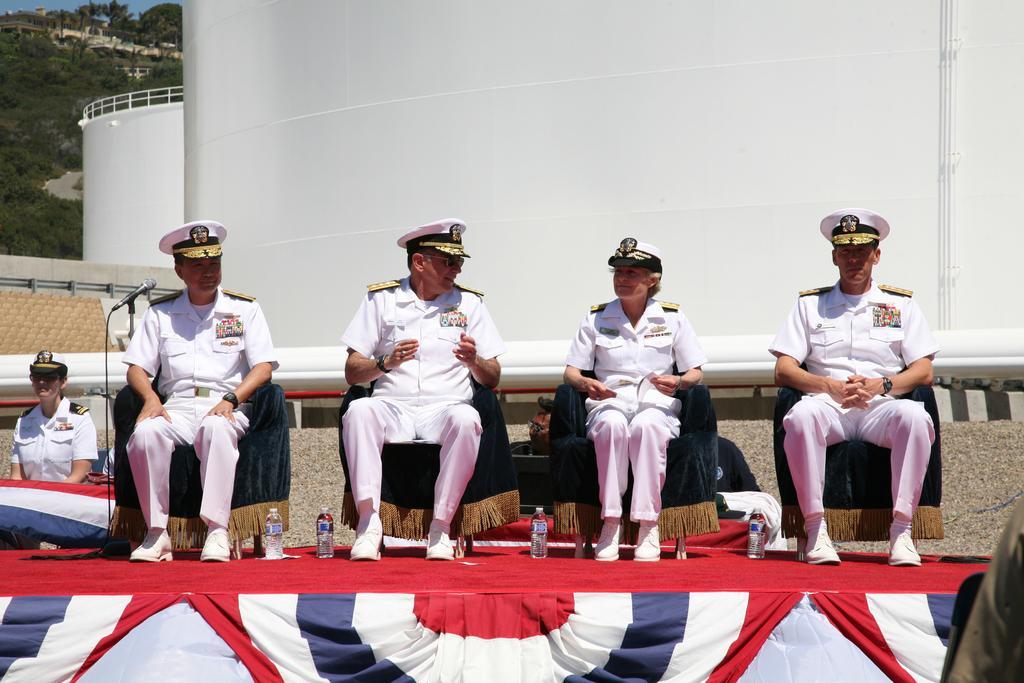How would you summarize this image in a sentence or two? In this image there are four people in the uniform are sitting on the stage, there are water bottles on the stage, there is a another person in the uniform near the stage, there are two constructed tanks, a fence, buildings and trees. 